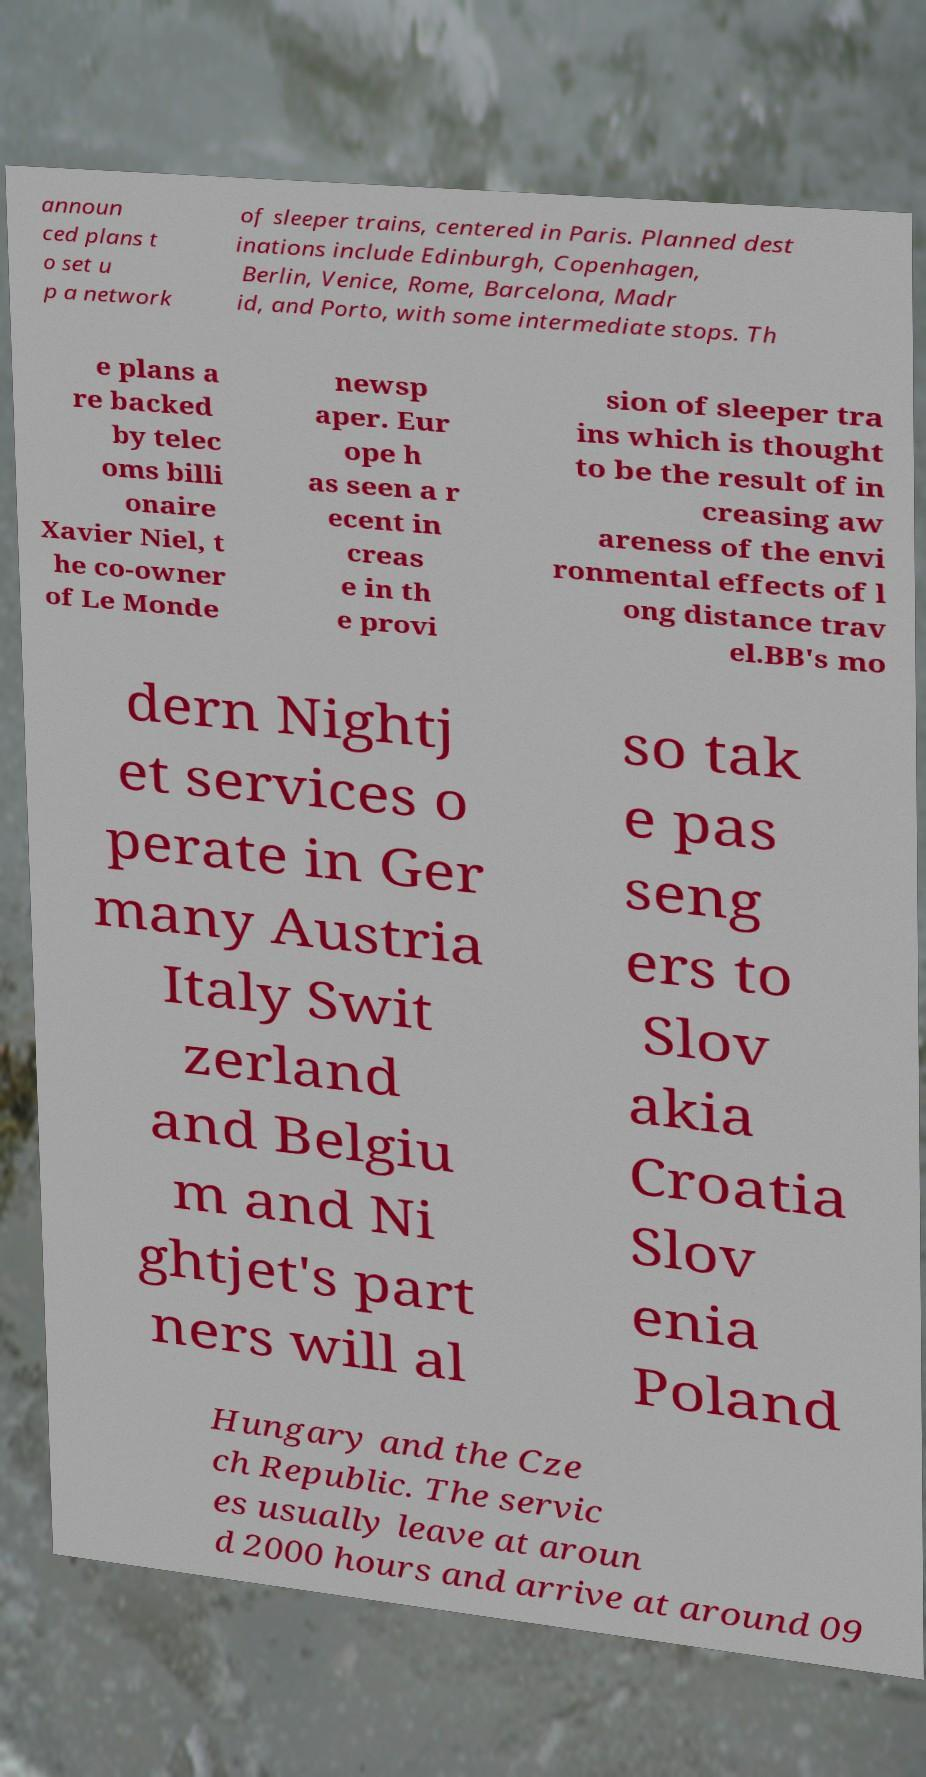Could you extract and type out the text from this image? announ ced plans t o set u p a network of sleeper trains, centered in Paris. Planned dest inations include Edinburgh, Copenhagen, Berlin, Venice, Rome, Barcelona, Madr id, and Porto, with some intermediate stops. Th e plans a re backed by telec oms billi onaire Xavier Niel, t he co-owner of Le Monde newsp aper. Eur ope h as seen a r ecent in creas e in th e provi sion of sleeper tra ins which is thought to be the result of in creasing aw areness of the envi ronmental effects of l ong distance trav el.BB's mo dern Nightj et services o perate in Ger many Austria Italy Swit zerland and Belgiu m and Ni ghtjet's part ners will al so tak e pas seng ers to Slov akia Croatia Slov enia Poland Hungary and the Cze ch Republic. The servic es usually leave at aroun d 2000 hours and arrive at around 09 